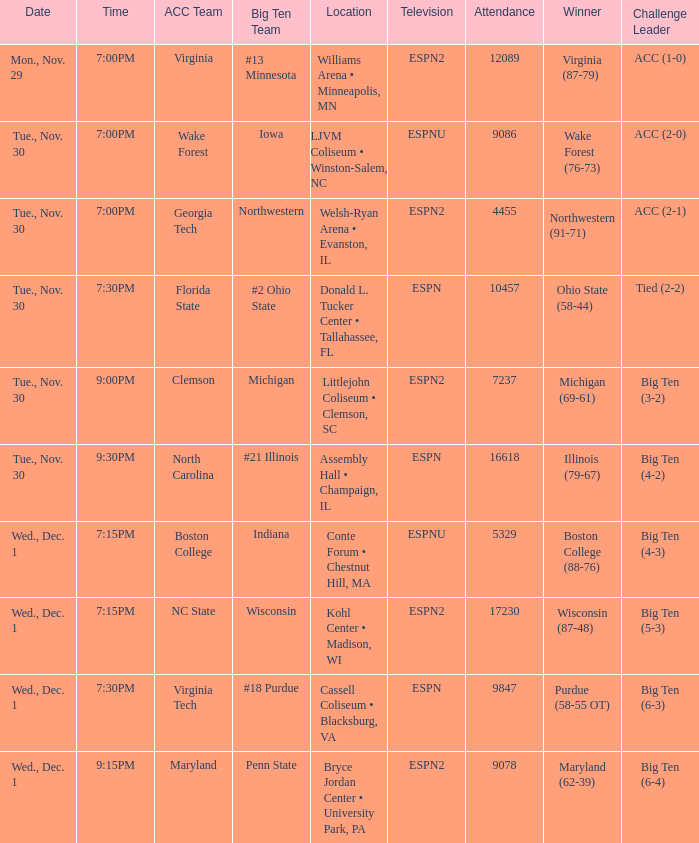In which locations were the games featuring wake forest as an acc team held? LJVM Coliseum • Winston-Salem, NC. Could you parse the entire table as a dict? {'header': ['Date', 'Time', 'ACC Team', 'Big Ten Team', 'Location', 'Television', 'Attendance', 'Winner', 'Challenge Leader'], 'rows': [['Mon., Nov. 29', '7:00PM', 'Virginia', '#13 Minnesota', 'Williams Arena • Minneapolis, MN', 'ESPN2', '12089', 'Virginia (87-79)', 'ACC (1-0)'], ['Tue., Nov. 30', '7:00PM', 'Wake Forest', 'Iowa', 'LJVM Coliseum • Winston-Salem, NC', 'ESPNU', '9086', 'Wake Forest (76-73)', 'ACC (2-0)'], ['Tue., Nov. 30', '7:00PM', 'Georgia Tech', 'Northwestern', 'Welsh-Ryan Arena • Evanston, IL', 'ESPN2', '4455', 'Northwestern (91-71)', 'ACC (2-1)'], ['Tue., Nov. 30', '7:30PM', 'Florida State', '#2 Ohio State', 'Donald L. Tucker Center • Tallahassee, FL', 'ESPN', '10457', 'Ohio State (58-44)', 'Tied (2-2)'], ['Tue., Nov. 30', '9:00PM', 'Clemson', 'Michigan', 'Littlejohn Coliseum • Clemson, SC', 'ESPN2', '7237', 'Michigan (69-61)', 'Big Ten (3-2)'], ['Tue., Nov. 30', '9:30PM', 'North Carolina', '#21 Illinois', 'Assembly Hall • Champaign, IL', 'ESPN', '16618', 'Illinois (79-67)', 'Big Ten (4-2)'], ['Wed., Dec. 1', '7:15PM', 'Boston College', 'Indiana', 'Conte Forum • Chestnut Hill, MA', 'ESPNU', '5329', 'Boston College (88-76)', 'Big Ten (4-3)'], ['Wed., Dec. 1', '7:15PM', 'NC State', 'Wisconsin', 'Kohl Center • Madison, WI', 'ESPN2', '17230', 'Wisconsin (87-48)', 'Big Ten (5-3)'], ['Wed., Dec. 1', '7:30PM', 'Virginia Tech', '#18 Purdue', 'Cassell Coliseum • Blacksburg, VA', 'ESPN', '9847', 'Purdue (58-55 OT)', 'Big Ten (6-3)'], ['Wed., Dec. 1', '9:15PM', 'Maryland', 'Penn State', 'Bryce Jordan Center • University Park, PA', 'ESPN2', '9078', 'Maryland (62-39)', 'Big Ten (6-4)']]} 